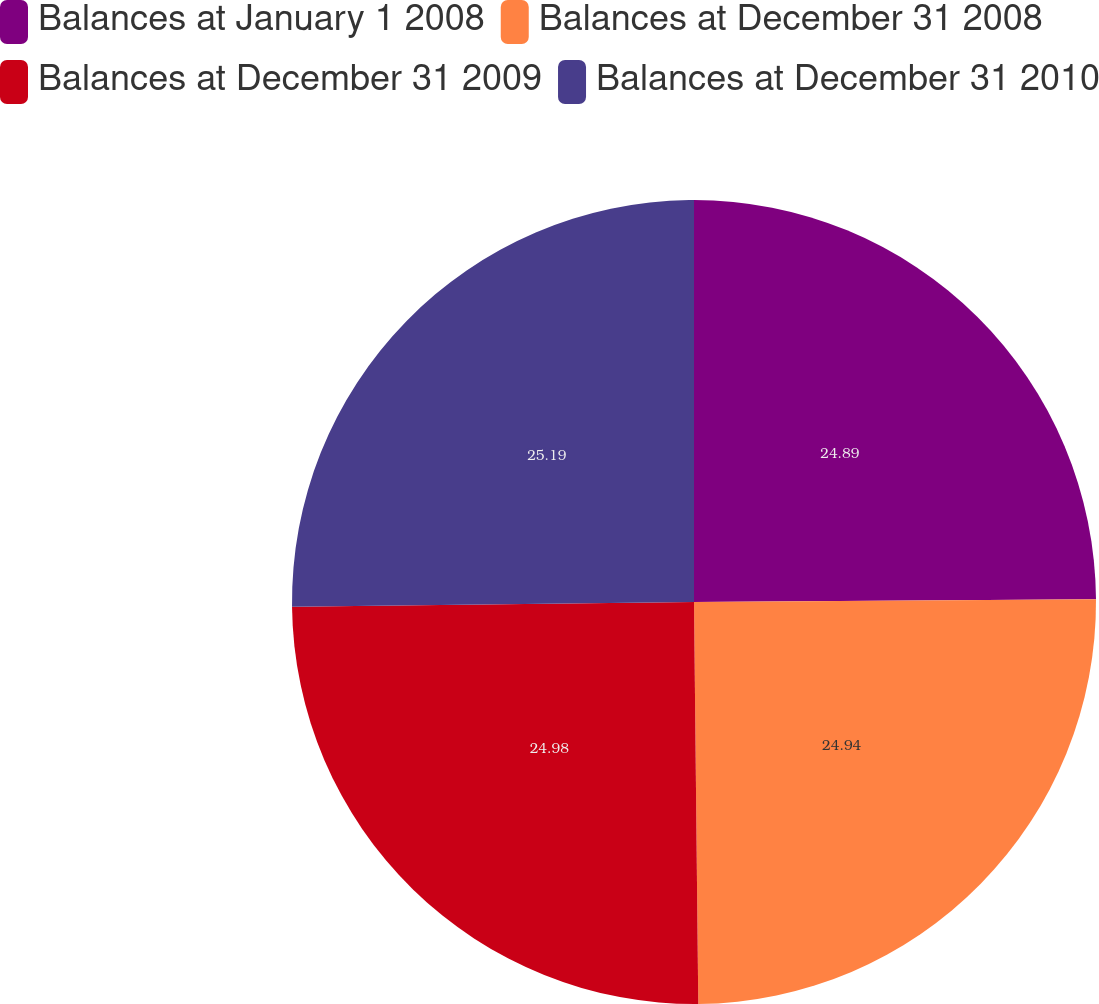Convert chart. <chart><loc_0><loc_0><loc_500><loc_500><pie_chart><fcel>Balances at January 1 2008<fcel>Balances at December 31 2008<fcel>Balances at December 31 2009<fcel>Balances at December 31 2010<nl><fcel>24.89%<fcel>24.94%<fcel>24.98%<fcel>25.19%<nl></chart> 